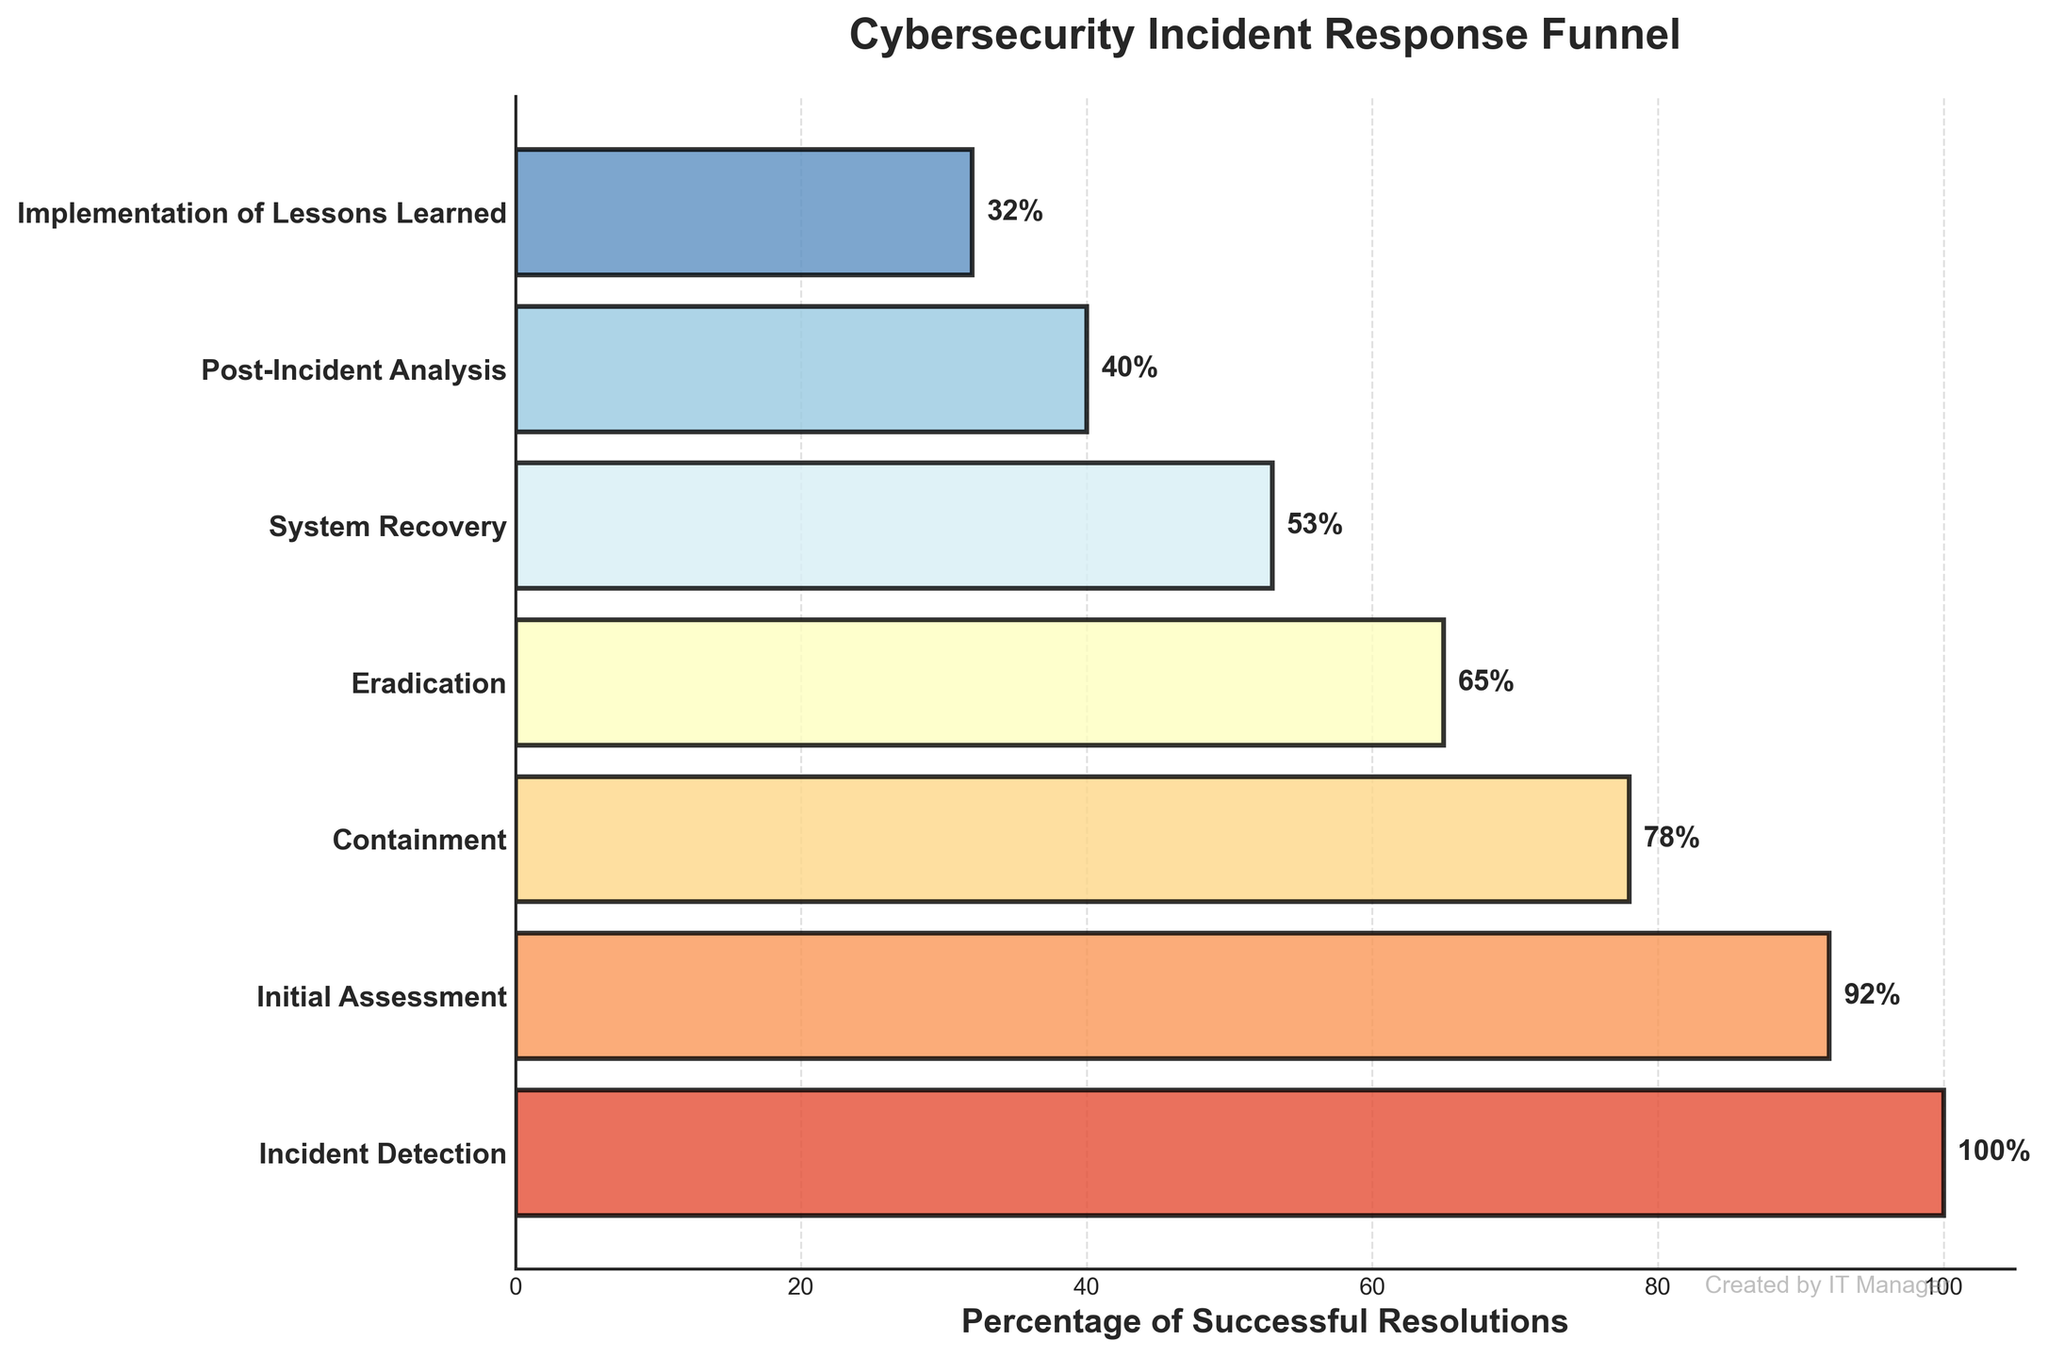What's the title of the figure? The title is usually displayed at the top of the chart. Here it states: 'Cybersecurity Incident Response Funnel'.
Answer: Cybersecurity Incident Response Funnel What is the percentage of successful resolutions at the Eradication stage? By looking at the corresponding value for the Eradication stage on the y-axis, we see that it is 65%.
Answer: 65% How many stages are included in the funnel chart? The y-axis lists the stages. Counting each listed stage from top to bottom, there are 7 stages.
Answer: 7 stages What percentage difference is there between the Initial Assessment and System Recovery stages? The Initial Assessment has 92% and System Recovery has 53%. The difference is calculated as 92 - 53.
Answer: 39% Which stage has the lowest percentage of successful resolutions? By examining the percentages listed, the 'Implementation of Lessons Learned' stage has the lowest value at 32%.
Answer: Implementation of Lessons Learned What color scheme is used to represent the different stages in the funnel chart? The color scheme used is from the RdYlBu colormap, which ranges from red to yellow to blue.
Answer: RdYlBu colormap Which stage experiences the greatest decrease in percentage compared to its previous stage? Comparing the differences between each consecutive stage: Initial Assessment (92) vs. Containment (78) is 14, Containment (78) vs. Eradication (65) is 13, Eradication (65) vs. System Recovery (53) is 12, System Recovery (53) vs. Post-Incident Analysis (40) is 13, and Post-Incident Analysis (40) vs. Implementation of Lessons Learned (32) is 8. Therefore, the greatest decrease is between Initial Assessment and Containment (14%).
Answer: Between Initial Assessment and Containment What is the visual appearance of the watermark text on the plot? The watermark-like text is located at the bottom right and states 'Created by IT Manager' in small, gray-colored text.
Answer: Created by IT Manager What percentage of successful resolutions drops after the Containment stage? The percentage at the Containment stage is 78%, and the next stage Eradication is at 65%. The drop is calculated as 78 - 65.
Answer: 13% What is the average percentage of successful resolutions from all stages? Summing up all percentages: 100 + 92 + 78 + 65 + 53 + 40 + 32 = 460. Dividing this sum by the number of stages (7): 460 / 7.
Answer: Approximately 65.71% What's the overall trend seen in the percentages of successful resolutions across the stages? The percentages steadily decrease from Incident Detection at 100% to Implementation of Lessons Learned at 32%, indicating a downward trend in successful resolutions as stages progress.
Answer: Downward trend 